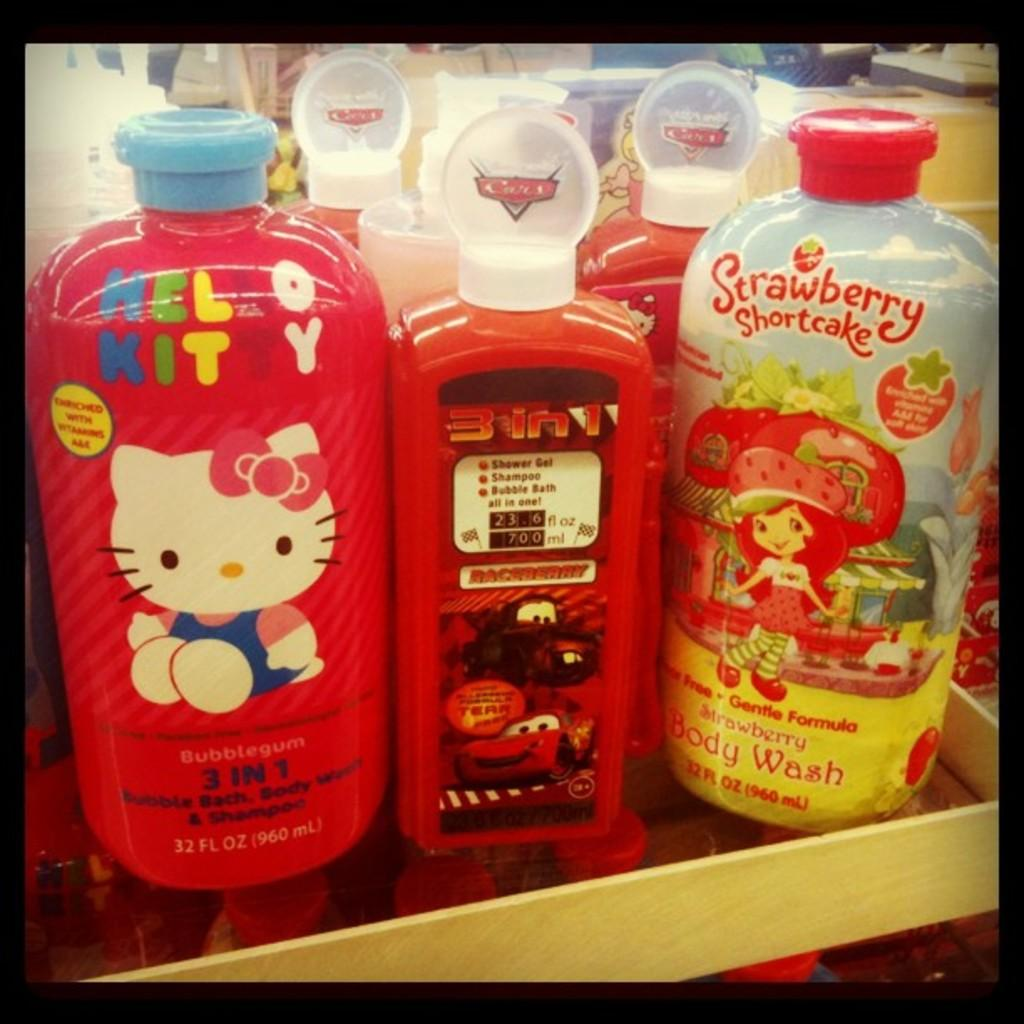What is located on the platform in the image? There are bottles on a platform in the image. Can you describe the objects visible in the background of the image? Unfortunately, the provided facts do not give any information about the objects visible in the background. What type of punishment is being administered to the visitor in the image? There is no visitor or punishment present in the image; it only features bottles on a platform. 